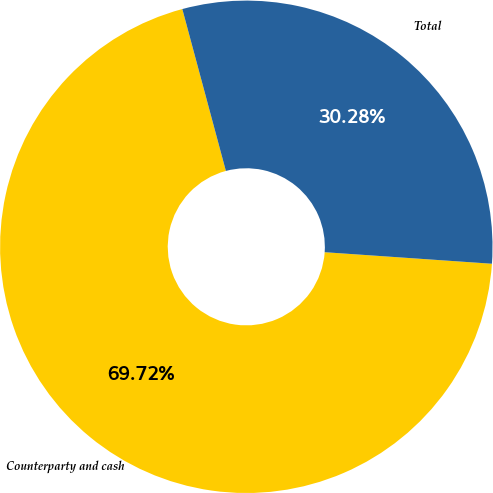<chart> <loc_0><loc_0><loc_500><loc_500><pie_chart><fcel>Counterparty and cash<fcel>Total<nl><fcel>69.72%<fcel>30.28%<nl></chart> 